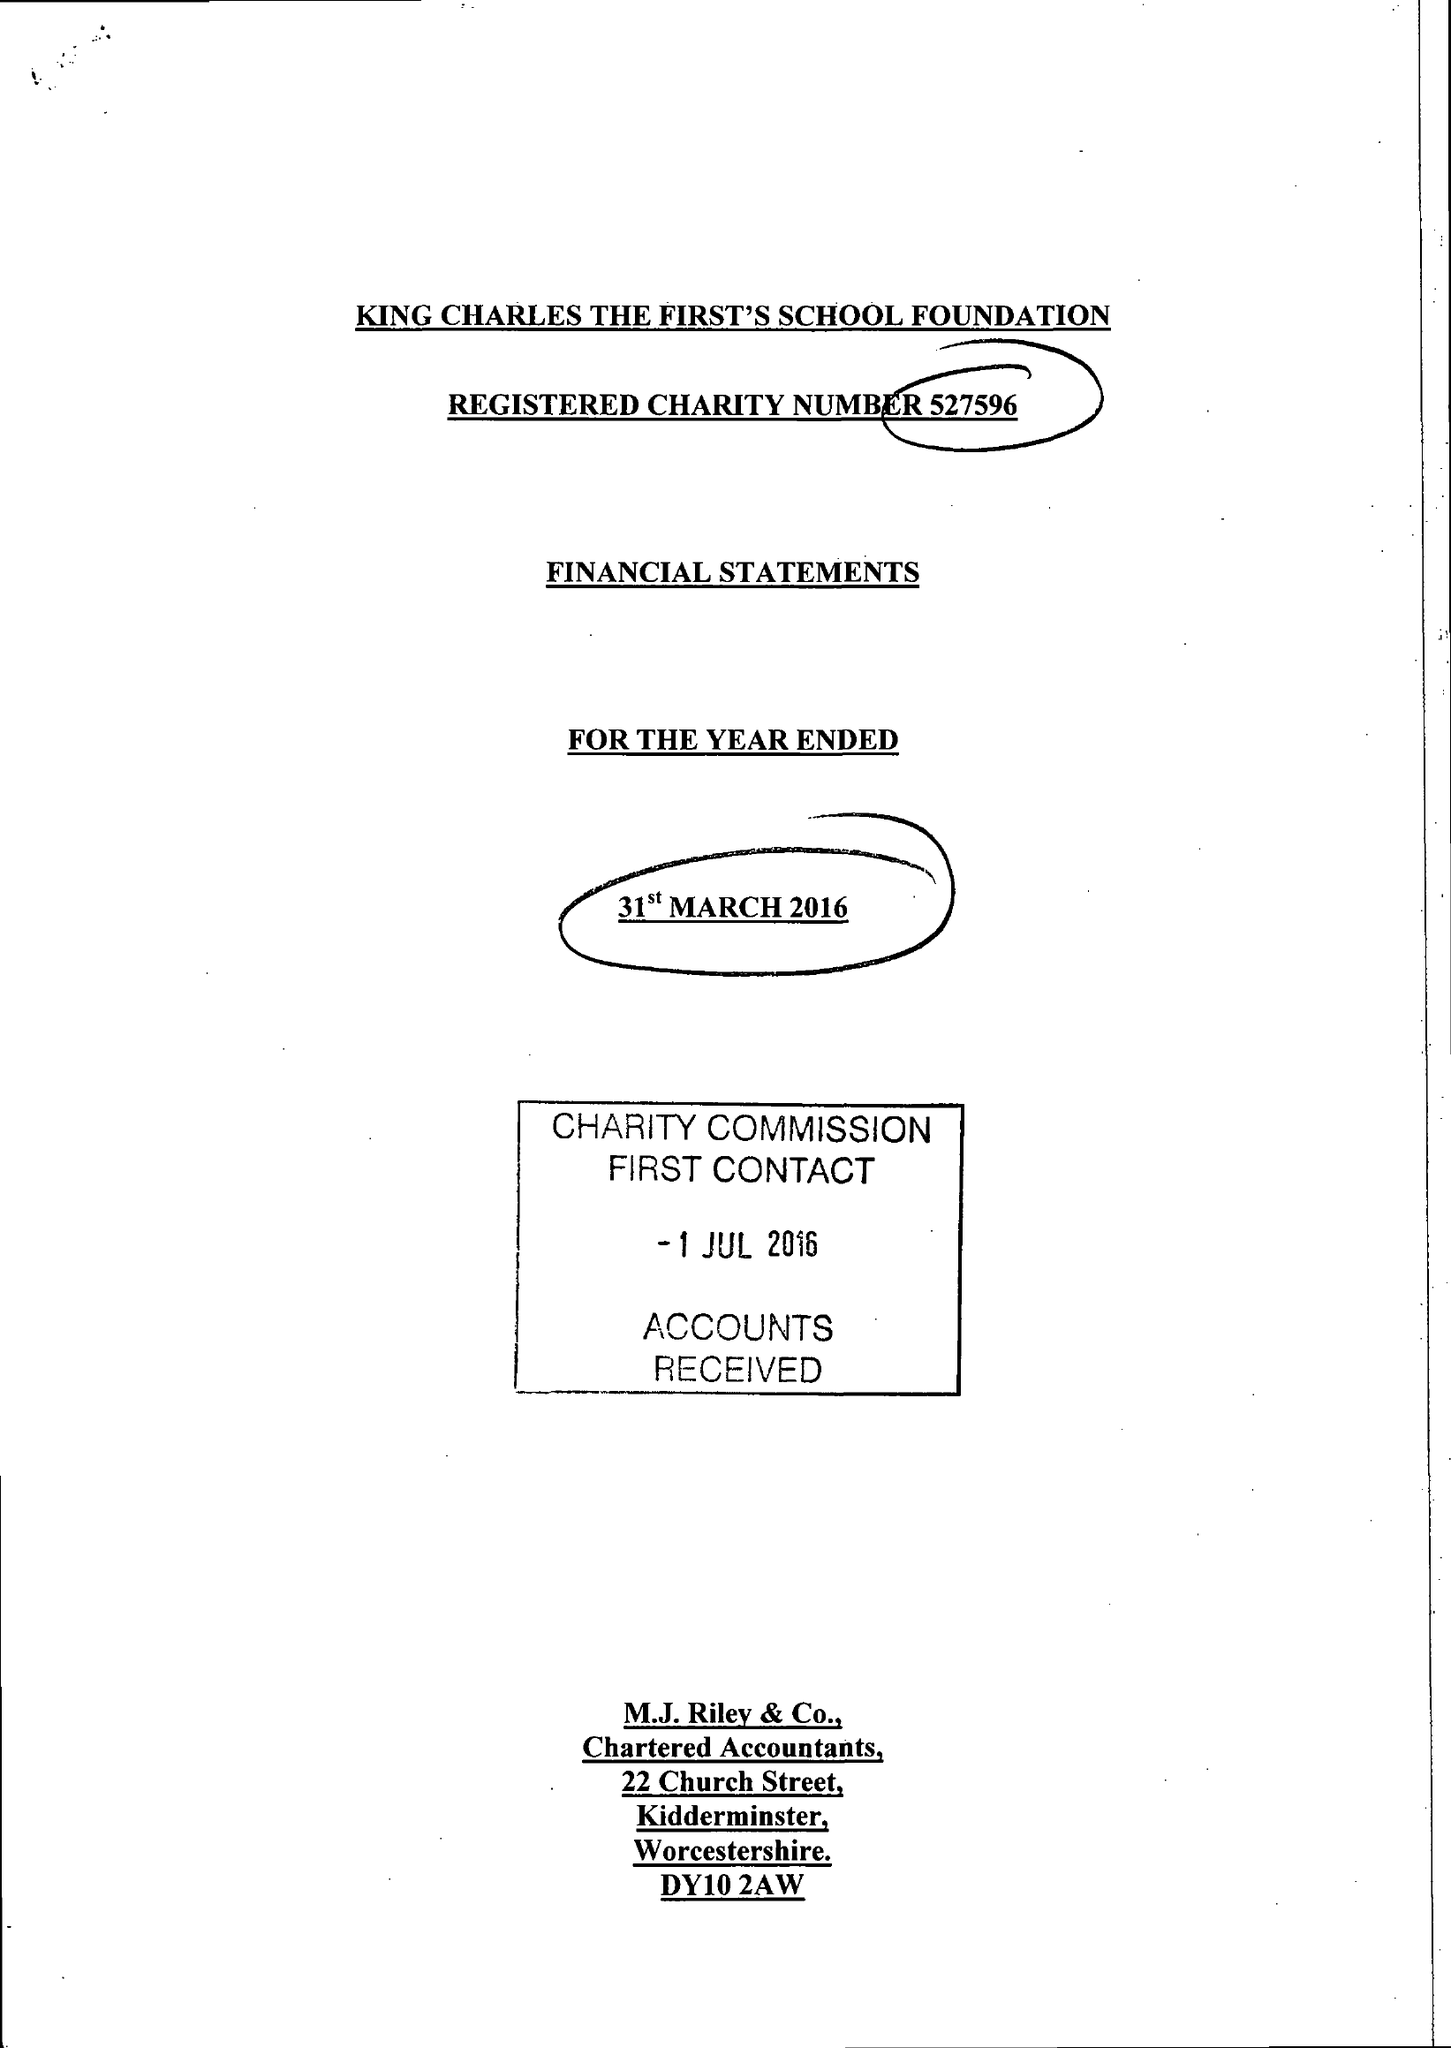What is the value for the address__post_town?
Answer the question using a single word or phrase. STOURPORT-ON-SEVERN 